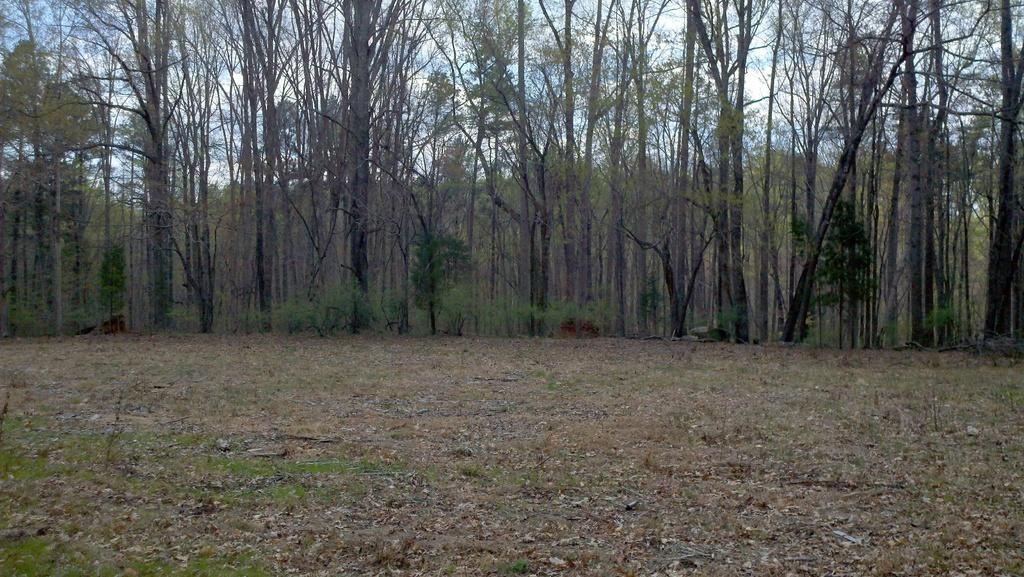What type of vegetation is visible at the bottom of the image? There is grass and dried leaves at the bottom of the image. What can be seen in the background of the image? There are many trees in the background of the image. What book is being read by the person in the image? There is no person present in the image, so it is not possible to determine if someone is reading a book. 